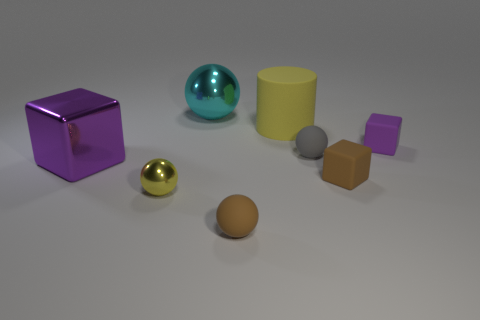What might be the purpose of this collection of objects? This collection of objects could serve several purposes. It might be a 3D render used for a visual exercise in a computer graphics program, designed to showcase different shapes, colors, and textures. Alternatively, it could be a part of a children's educational tool, used to teach about shapes, colors, and sizes. The variety in appearance amongst the objects suggests an intention to display contrast and comparison. 